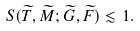Convert formula to latex. <formula><loc_0><loc_0><loc_500><loc_500>S ( \widetilde { T } , \widetilde { M } ; \widetilde { G } , \widetilde { F } ) \lesssim 1 .</formula> 